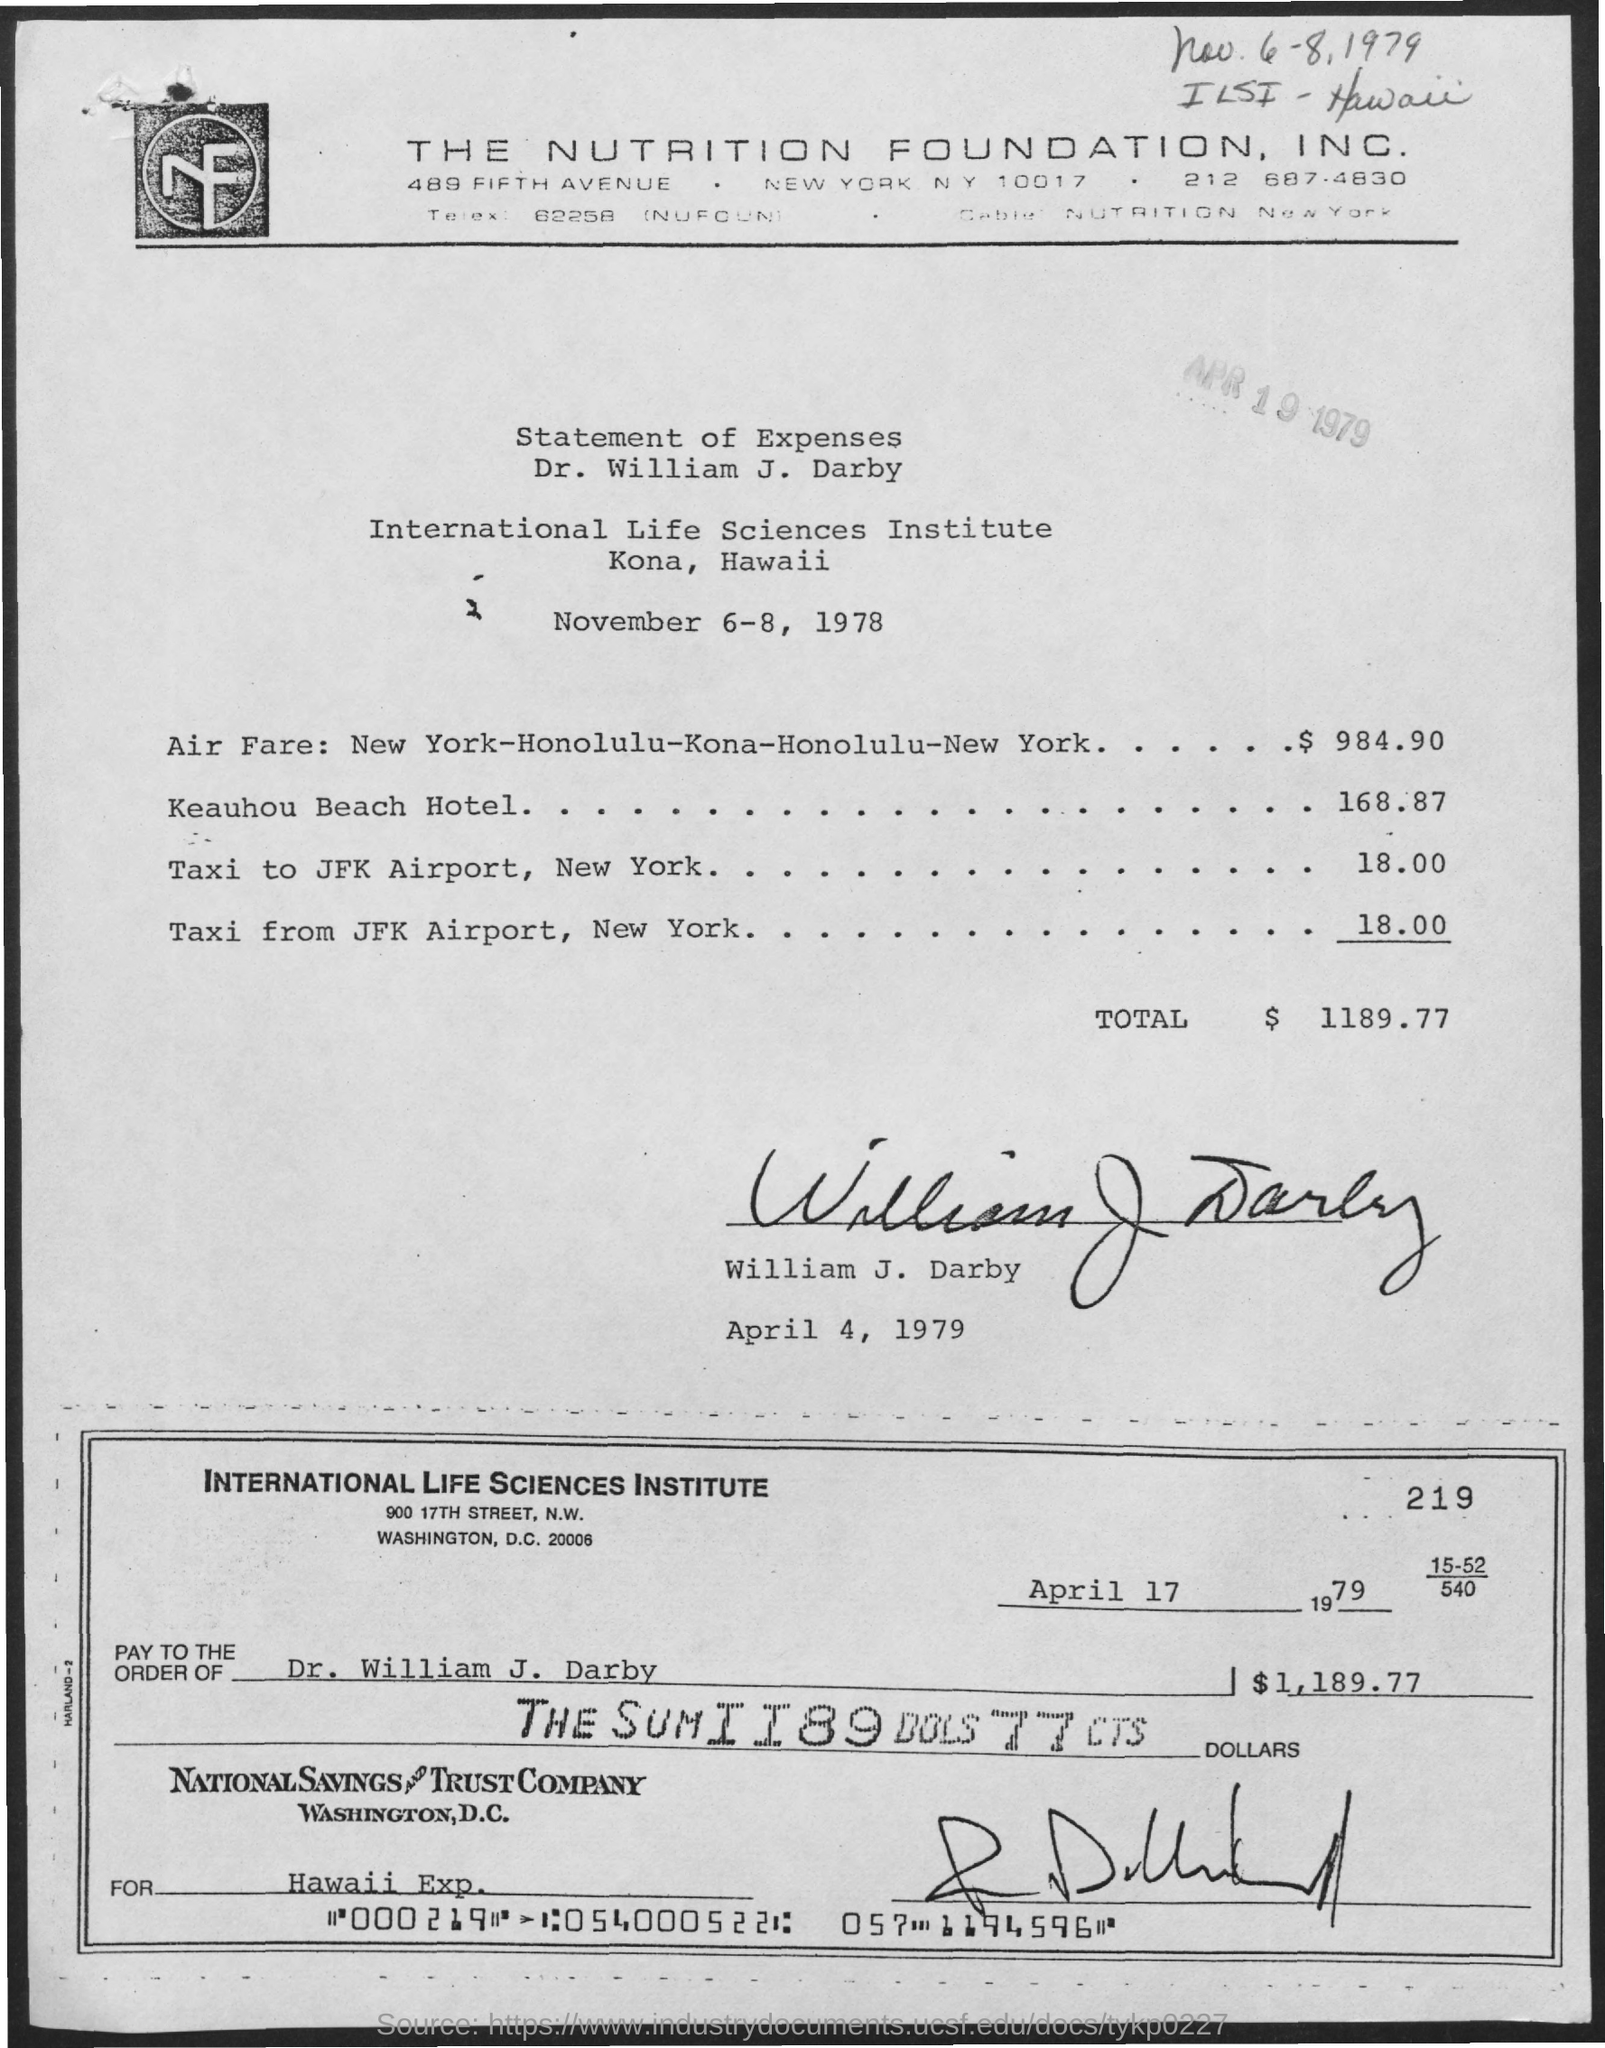What is the name of the institute ?
Make the answer very short. International life sciences institute. What are the expenses for air fare :new york- honolulu-kona-honolulu-new york ?
Offer a very short reply. $ 984.90. What are the expenses for keauhou beach hotel ?
Provide a succinct answer. $ 168.87. What are the total expenses mentioned in the given page ?
Give a very brief answer. $ 1189.77. What is the date mentioned in the given check ?
Your answer should be compact. April 17, 1979. Who's name was written at pay to the order of as mentioned in the given check ?
Offer a very short reply. Dr. William J. Darby. What is the amount mentioned in the given check ?
Make the answer very short. $ 1,189.77. 